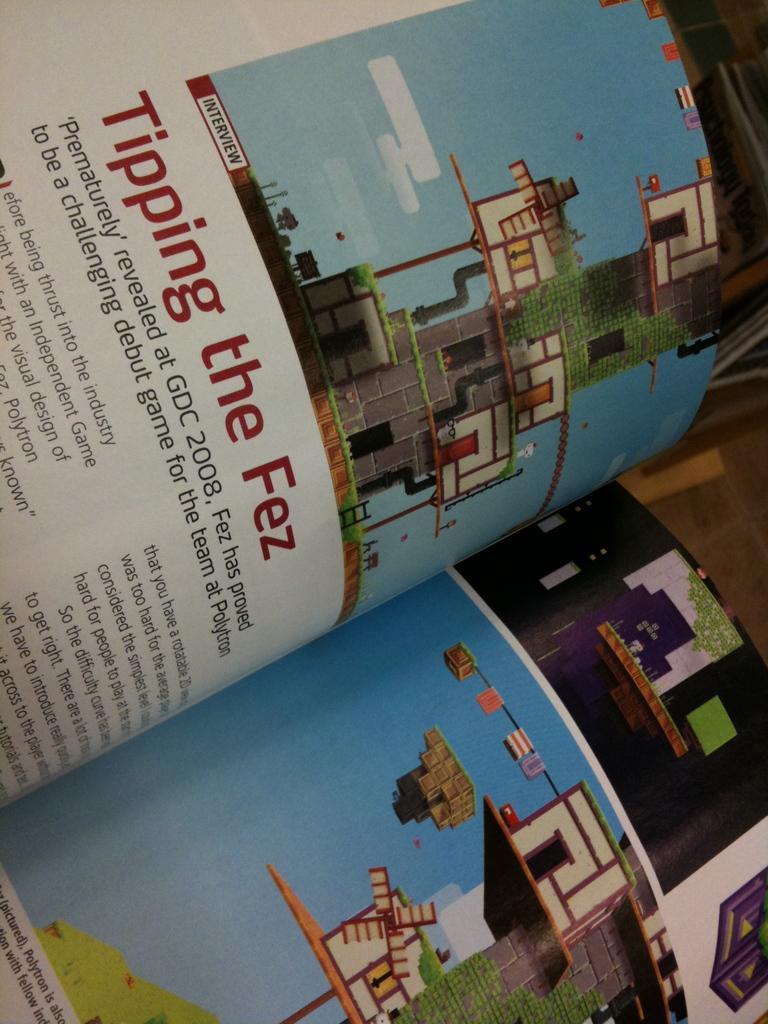What game is this article talking about?
Your answer should be very brief. Fez. How was the game revealed?
Keep it short and to the point. Prematurely. 